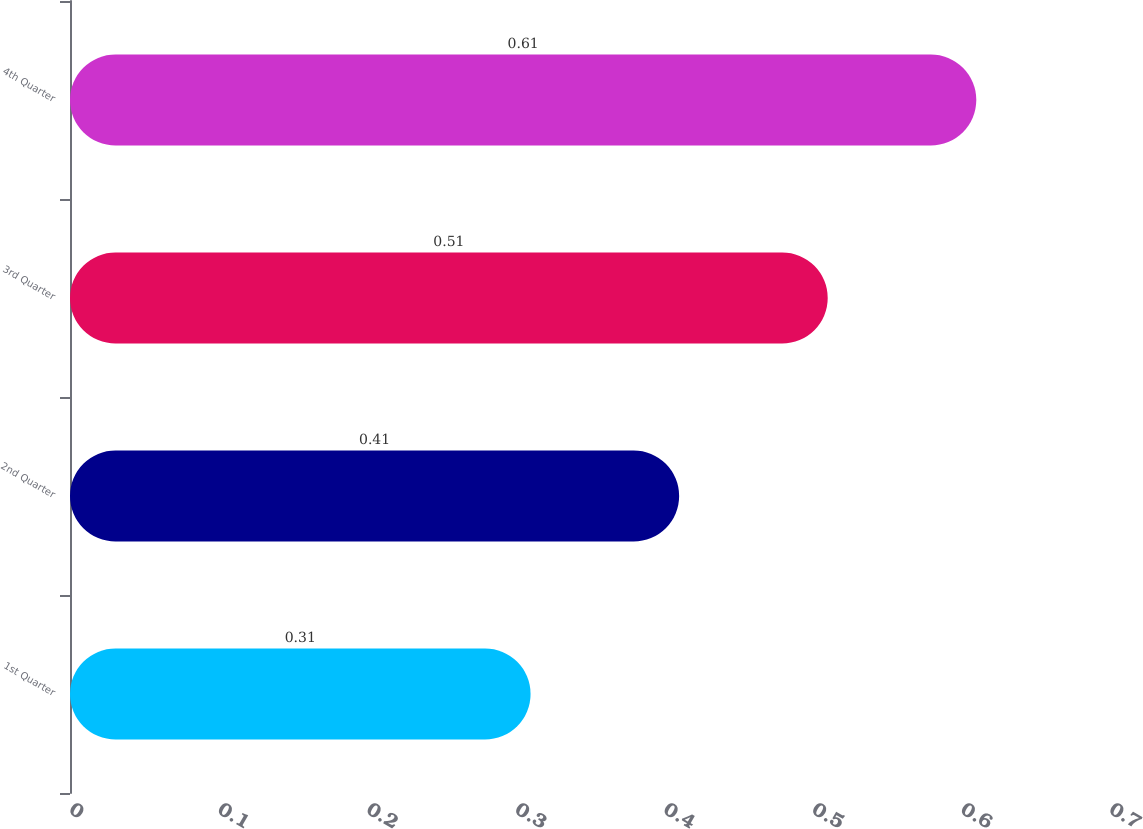Convert chart. <chart><loc_0><loc_0><loc_500><loc_500><bar_chart><fcel>1st Quarter<fcel>2nd Quarter<fcel>3rd Quarter<fcel>4th Quarter<nl><fcel>0.31<fcel>0.41<fcel>0.51<fcel>0.61<nl></chart> 